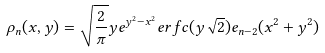<formula> <loc_0><loc_0><loc_500><loc_500>\rho _ { n } ( x , y ) = \sqrt { \frac { 2 } { \pi } } y e ^ { y ^ { 2 } - x ^ { 2 } } e r f c ( y \sqrt { 2 } ) e _ { n - 2 } ( x ^ { 2 } + y ^ { 2 } )</formula> 